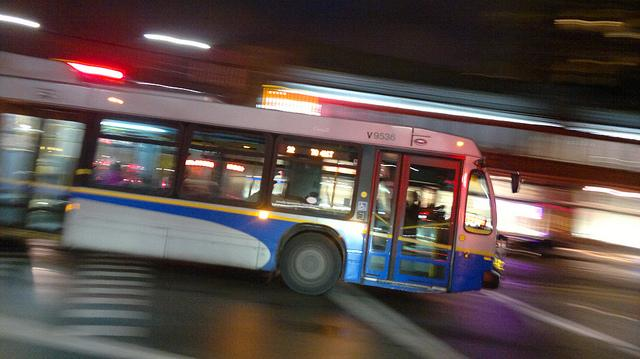Why is the bus blurred in the picture?

Choices:
A) cloudy lens
B) moving fast
C) flickering lights
D) wet paint moving fast 